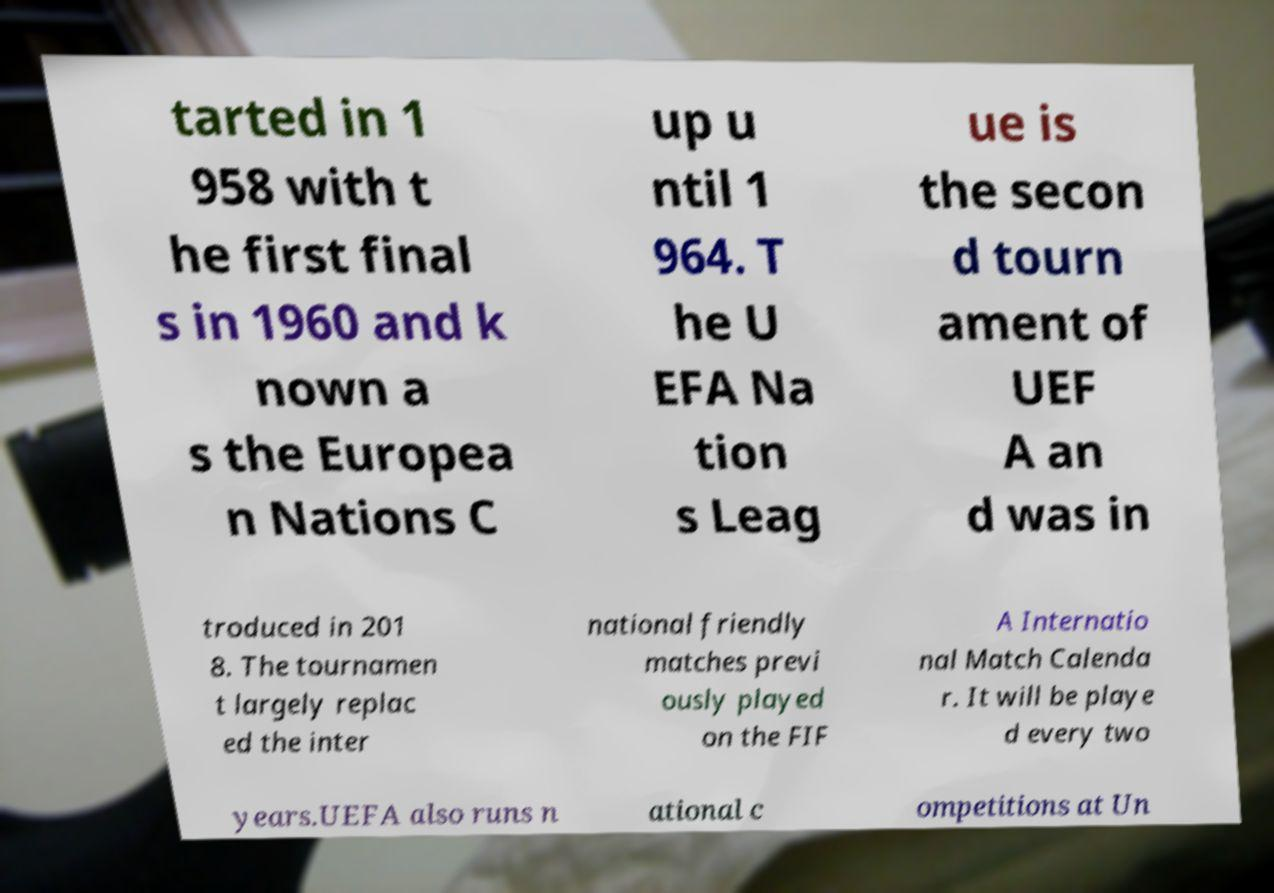Could you extract and type out the text from this image? tarted in 1 958 with t he first final s in 1960 and k nown a s the Europea n Nations C up u ntil 1 964. T he U EFA Na tion s Leag ue is the secon d tourn ament of UEF A an d was in troduced in 201 8. The tournamen t largely replac ed the inter national friendly matches previ ously played on the FIF A Internatio nal Match Calenda r. It will be playe d every two years.UEFA also runs n ational c ompetitions at Un 